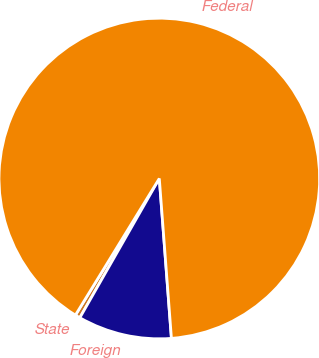Convert chart to OTSL. <chart><loc_0><loc_0><loc_500><loc_500><pie_chart><fcel>State<fcel>Foreign<fcel>Federal<nl><fcel>0.51%<fcel>9.46%<fcel>90.03%<nl></chart> 